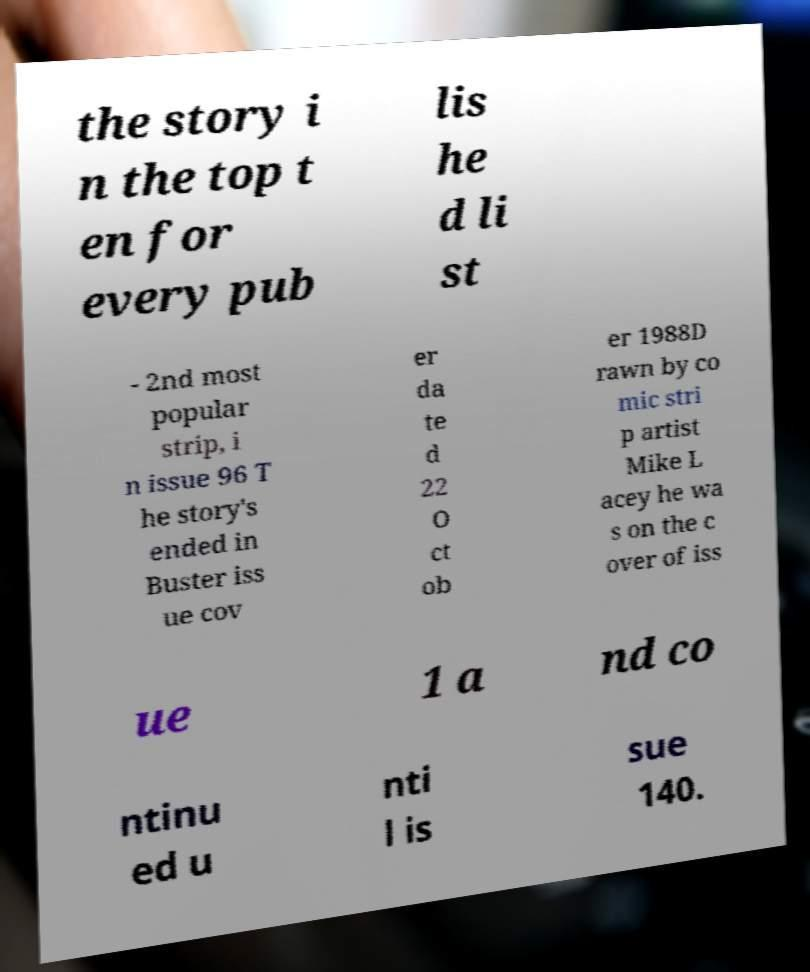Can you read and provide the text displayed in the image?This photo seems to have some interesting text. Can you extract and type it out for me? the story i n the top t en for every pub lis he d li st - 2nd most popular strip, i n issue 96 T he story's ended in Buster iss ue cov er da te d 22 O ct ob er 1988D rawn by co mic stri p artist Mike L acey he wa s on the c over of iss ue 1 a nd co ntinu ed u nti l is sue 140. 